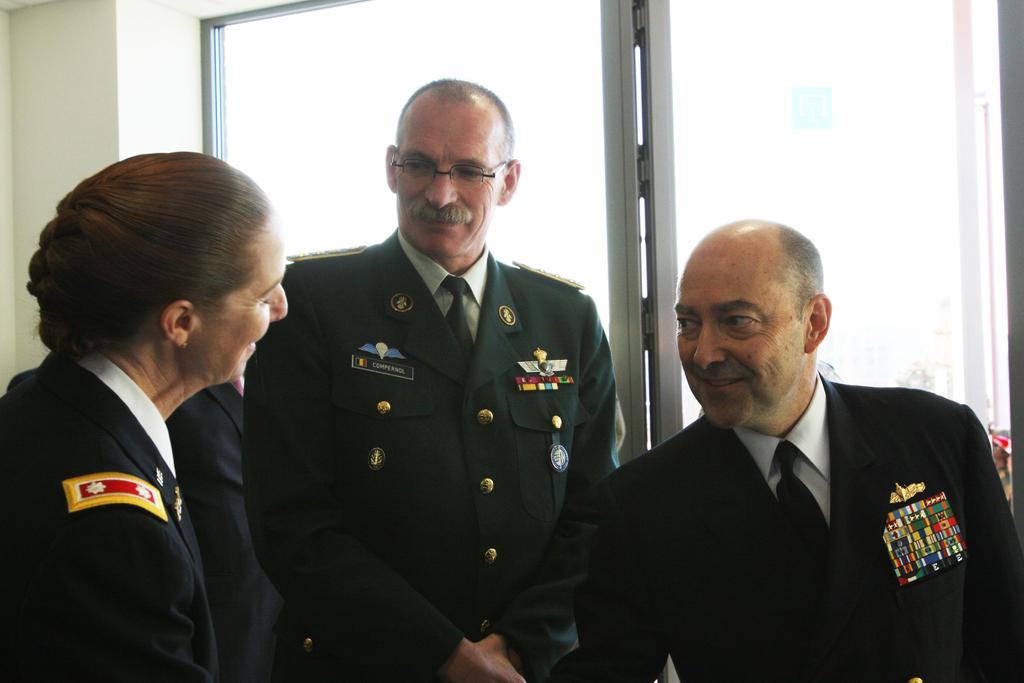How many people are in the image? There are three people in the image: a woman and two men. What are the people in the image doing? They are all standing near a glass window and smiling. What are the people wearing? They are wearing uniforms. What type of veil can be seen on the woman in the image? There is no veil present on the woman in the image; she is wearing a uniform like the men. Is there a boat visible in the image? There is no boat present in the image; the people are standing near a glass window. 